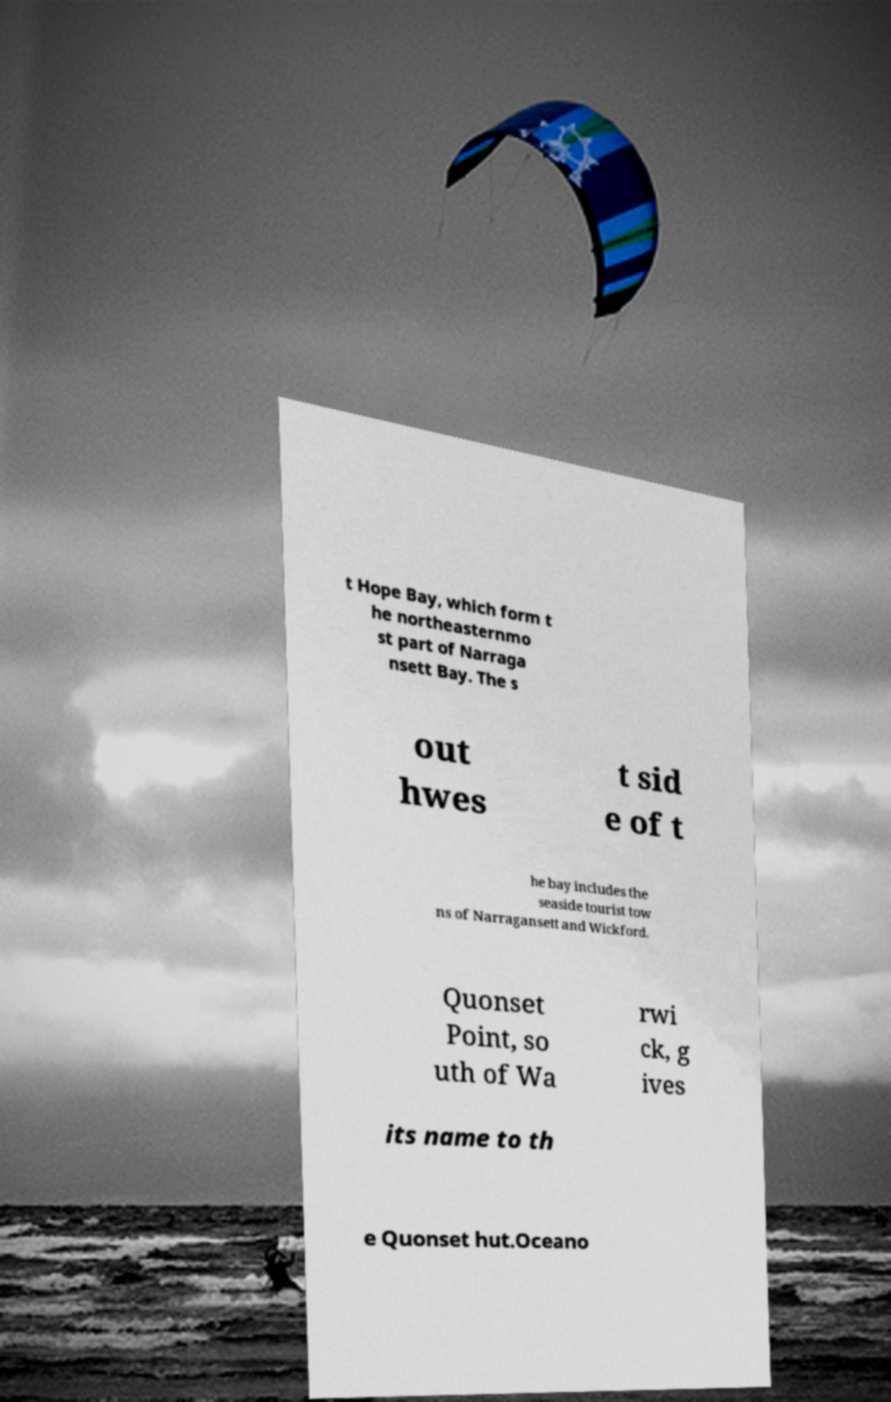Please read and relay the text visible in this image. What does it say? t Hope Bay, which form t he northeasternmo st part of Narraga nsett Bay. The s out hwes t sid e of t he bay includes the seaside tourist tow ns of Narragansett and Wickford. Quonset Point, so uth of Wa rwi ck, g ives its name to th e Quonset hut.Oceano 